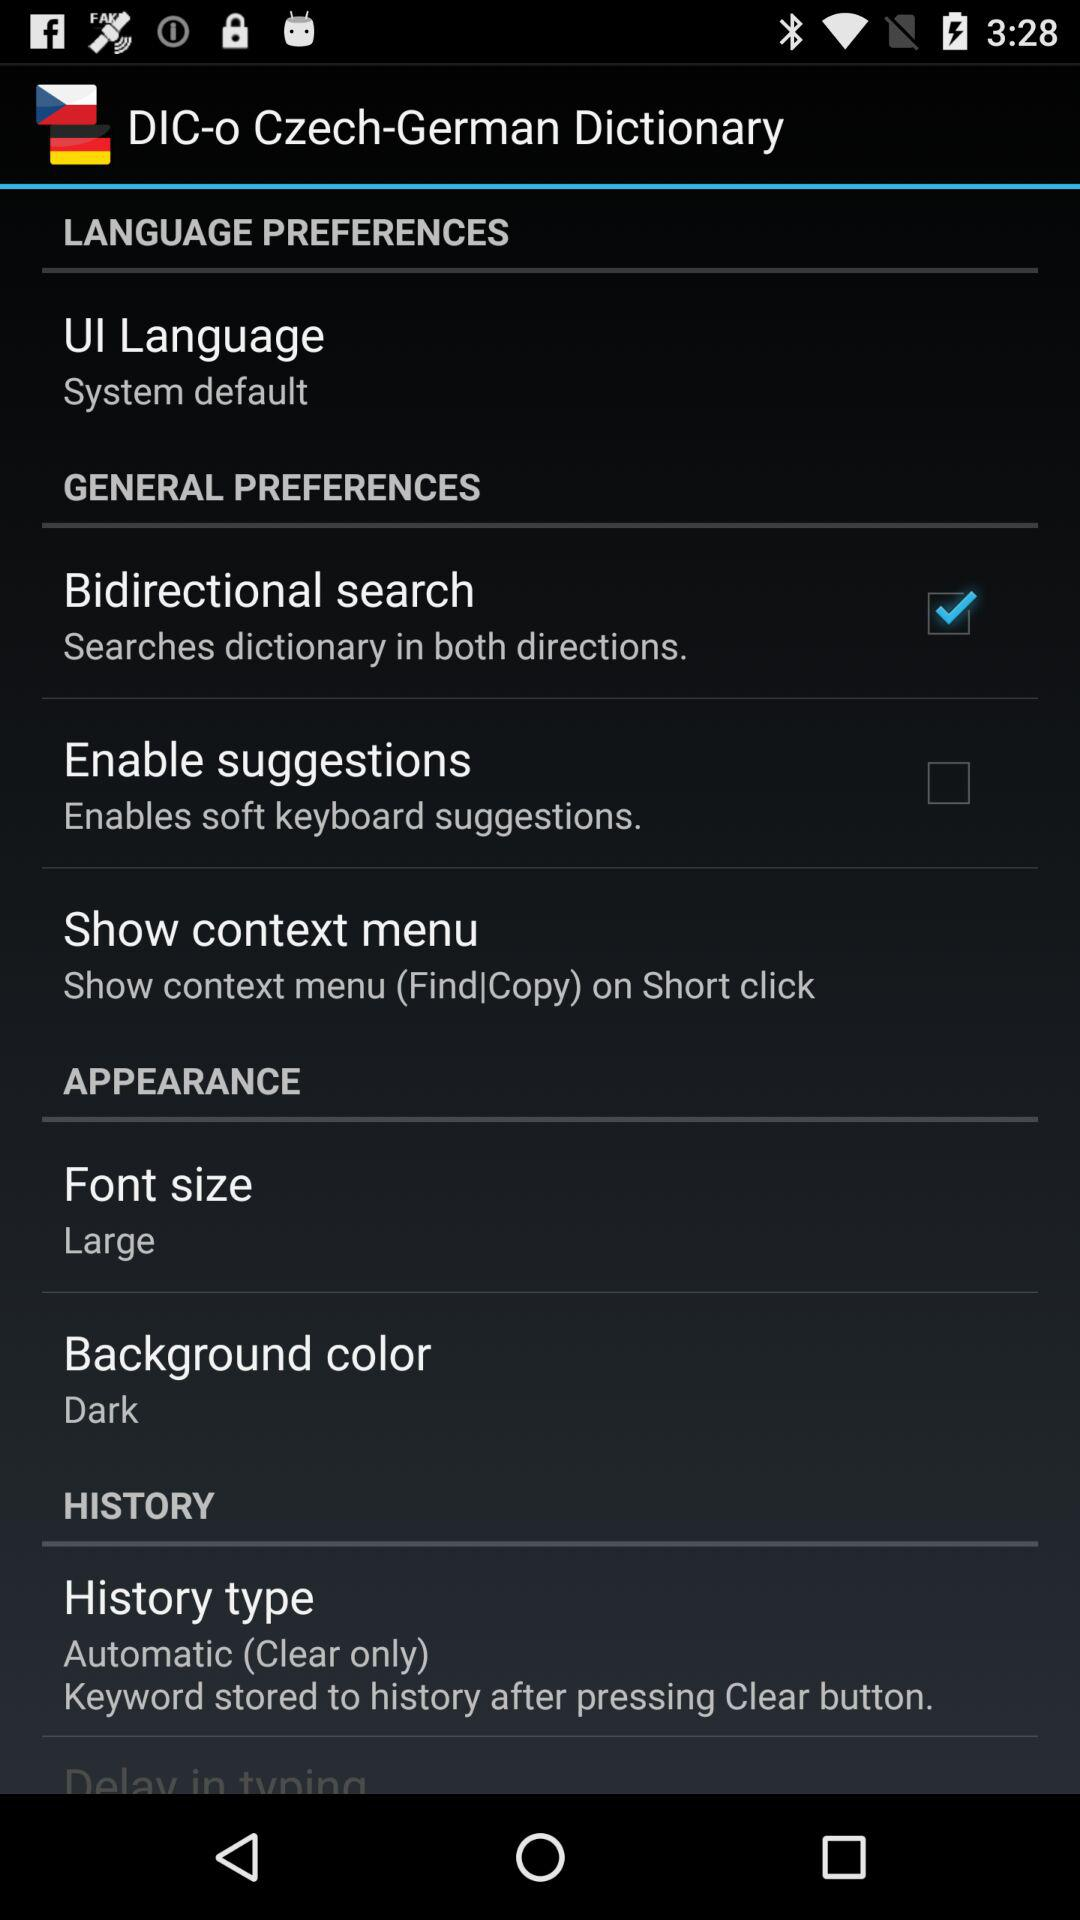How many items are there in the appearance section?
Answer the question using a single word or phrase. 2 